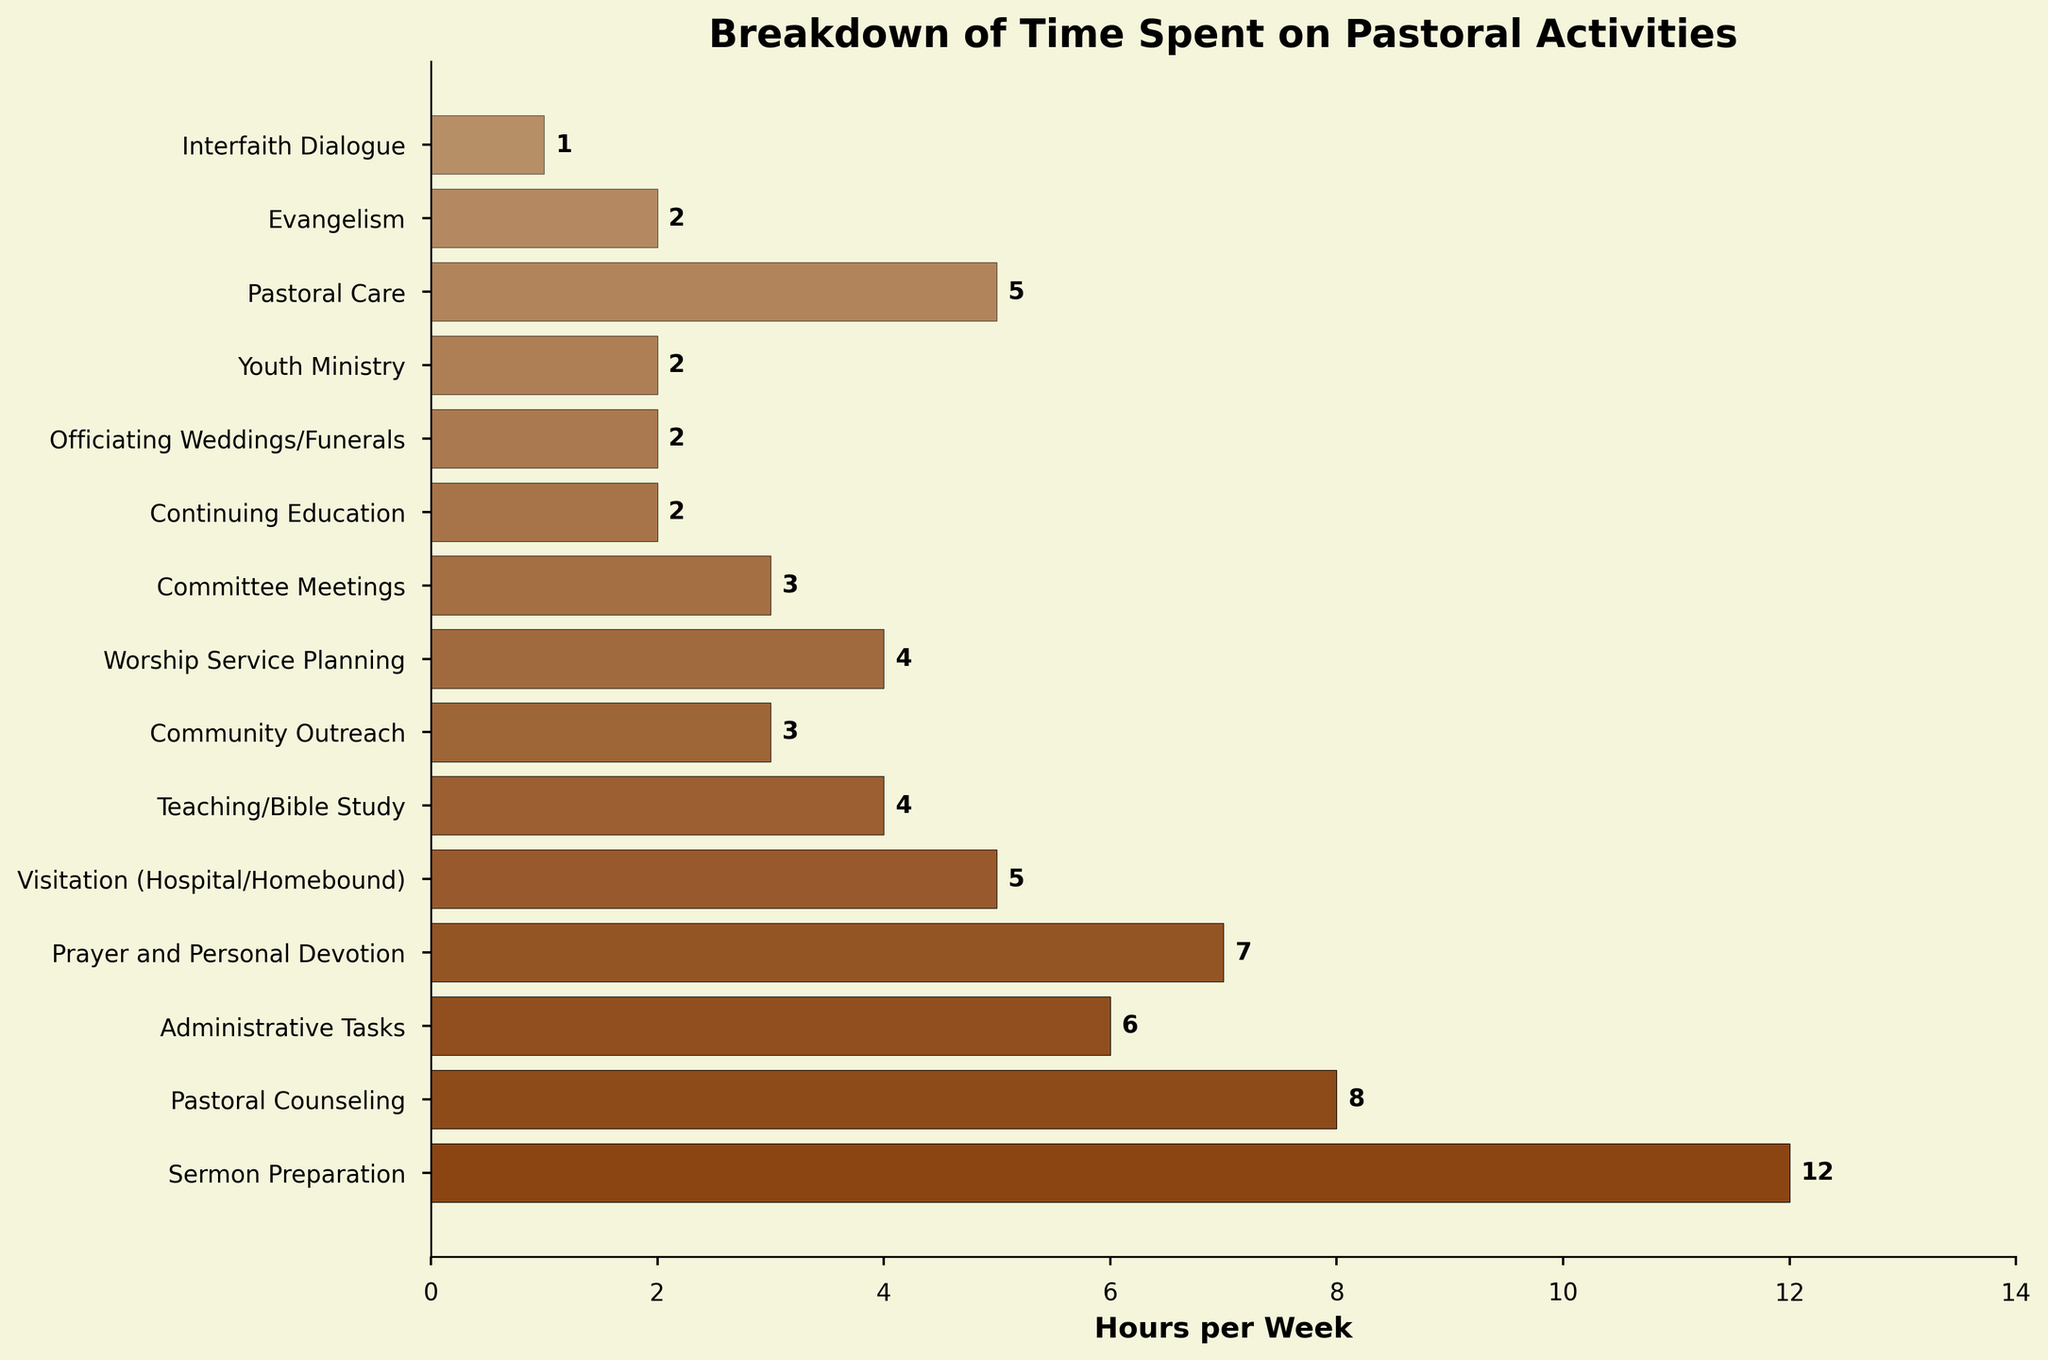How many hours per week do clergy members spend on prayer and personal devotion compared to community outreach? To find the answer, look at the bars representing "Prayer and Personal Devotion" and "Community Outreach." The first one shows 7 hours, while the latter shows 3 hours. Subtract 3 from 7.
Answer: 4 hours more What is the total time spent on visitation (hospital/homebound) and youth ministry per week? Add the hours for "Visitation (Hospital/Homebound)" and "Youth Ministry." That is 5 hours (Visitation) + 2 hours (Youth Ministry).
Answer: 7 hours Which activity takes up exactly 4 hours per week, and how many activities have this amount? Identify the activities that have bars reaching the 4-hour mark. Both "Teaching/Bible Study" and "Worship Service Planning" are at 4 hours each.
Answer: 2 activities What is the most time-consuming activity, and how many hours per week does it take? Find the activity with the longest bar. "Sermon Preparation" is the longest, showing 12 hours per week.
Answer: Sermon Preparation, 12 hours How many hours are spent on administrative tasks relative to pastoral counseling each week? Check the bars for "Administrative Tasks" and "Pastoral Counseling." Administrative Tasks are 6 hours, and Pastoral Counseling is 8 hours. Subtract the smaller from the larger value.
Answer: 2 hours less on Administrative Tasks Which activities take the least time each week, and how many hours are they? Look for the shortest bars in the chart. "Interfaith Dialogue" is the shortest, showing 1 hour per week.
Answer: Interfaith Dialogue, 1 hour How does the time spent on teaching/Bible study compare to continuing education per week? Observe the bars for "Teaching/Bible Study" and "Continuing Education." Teaching/Bible Study is at 4 hours, and Continuing Education is at 2 hours. Subtract 2 from 4.
Answer: 2 hours more What is the combined time spent on all activities that involve direct interaction with the community (e.g., community outreach, visitation, and pastoral care)? Add the hours for "Community Outreach" (3), "Visitation (Hospital/Homebound)" (5), and "Pastoral Care" (5).
Answer: 13 hours What is the difference in hours between sermon preparation and prayer and personal devotion? Check the bars for "Sermon Preparation" (12 hours) and "Prayer and Personal Devotion" (7 hours). Subtract 7 from 12.
Answer: 5 hours Which activities take exactly twice as much time as interfaith dialogue, and what are their hours? Look for activities whose bars are twice the size of Interfaith Dialogue's 1 hour. "Continuing Education," "Evangelism," "Youth Ministry," and "Officiating Weddings/Funerals" each take 2 hours, which is twice 1.
Answer: 4 activities, 2 hours each 